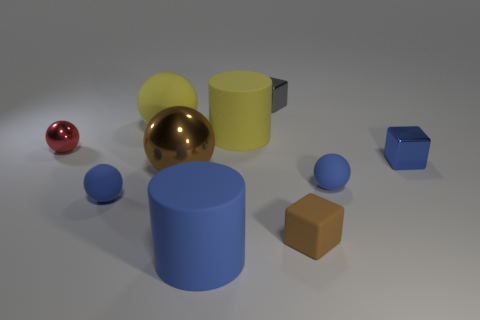Subtract 2 balls. How many balls are left? 3 Subtract all brown spheres. How many spheres are left? 4 Subtract all yellow spheres. How many spheres are left? 4 Subtract all green spheres. Subtract all yellow cylinders. How many spheres are left? 5 Subtract all cylinders. How many objects are left? 8 Subtract all small matte spheres. Subtract all gray cubes. How many objects are left? 7 Add 3 tiny brown cubes. How many tiny brown cubes are left? 4 Add 1 large objects. How many large objects exist? 5 Subtract 1 brown blocks. How many objects are left? 9 